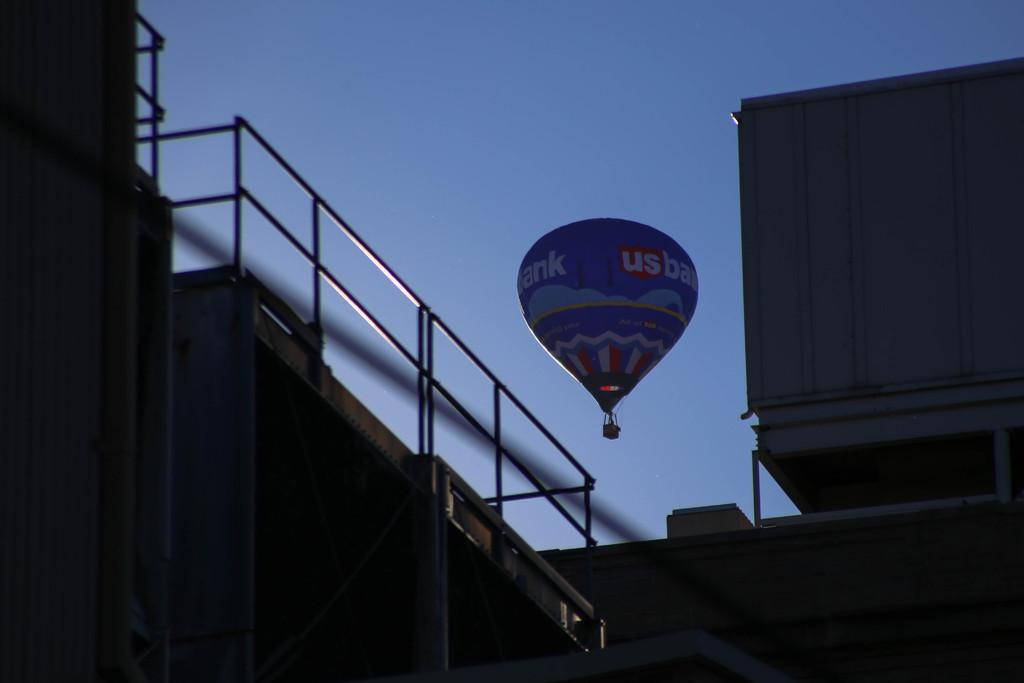What is the main subject in the sky in the image? There is an air balloon in the sky in the image. Where is the air balloon located in relation to the rest of the image? The air balloon is in the center of the image. What can be seen in the foreground of the image? There are buildings in the foreground of the image. What is visible in the background of the image? The sky is visible in the background of the image. How many ants can be seen crawling on the air balloon in the image? There are no ants visible on the air balloon in the image. What type of pies are being served in the image? There are no pies present in the image. 